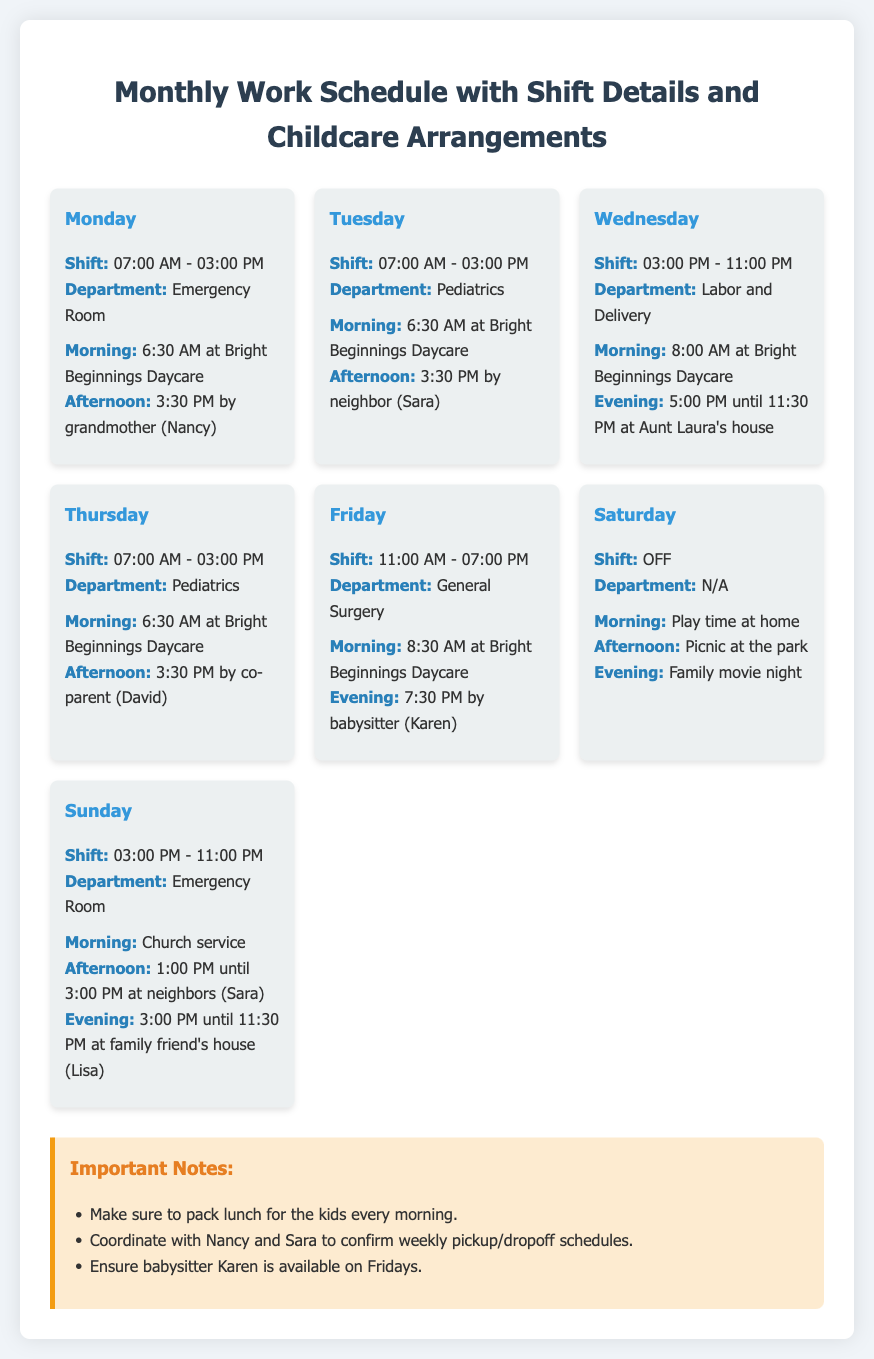what shift does the nurse work on Monday? The shift information for Monday is provided, specifying the start and end times of the shift.
Answer: 07:00 AM - 03:00 PM who will take care of the kids on Tuesday afternoon? The document indicates the person responsible for the kids during Tuesday afternoon, showing who will provide childcare.
Answer: neighbor (Sara) what is the morning childcare arrangement for Friday? The document states where the children will be during the Friday morning hours, specifying the location.
Answer: 8:30 AM at Bright Beginnings Daycare how long is the Sunday shift? The Sunday shift details include the starting and ending times, allowing for calculation of its duration.
Answer: 8 hours what activities are planned for Saturday afternoon? The document contains specific plans for Saturday afternoon, showing the activities lined up.
Answer: Picnic at the park who will take care of the kids on Wednesday evening? The childcare arrangement for Wednesday evening is specified in the document with the caregiver name.
Answer: Aunt Laura's house what is the department for the Thursday shift? The department information for the Thursday shift is provided and can be retrieved directly from the document.
Answer: Pediatrics how many hours does the nurse work on Friday? The shift timings for Friday allow for the calculation of total working hours.
Answer: 8 hours 